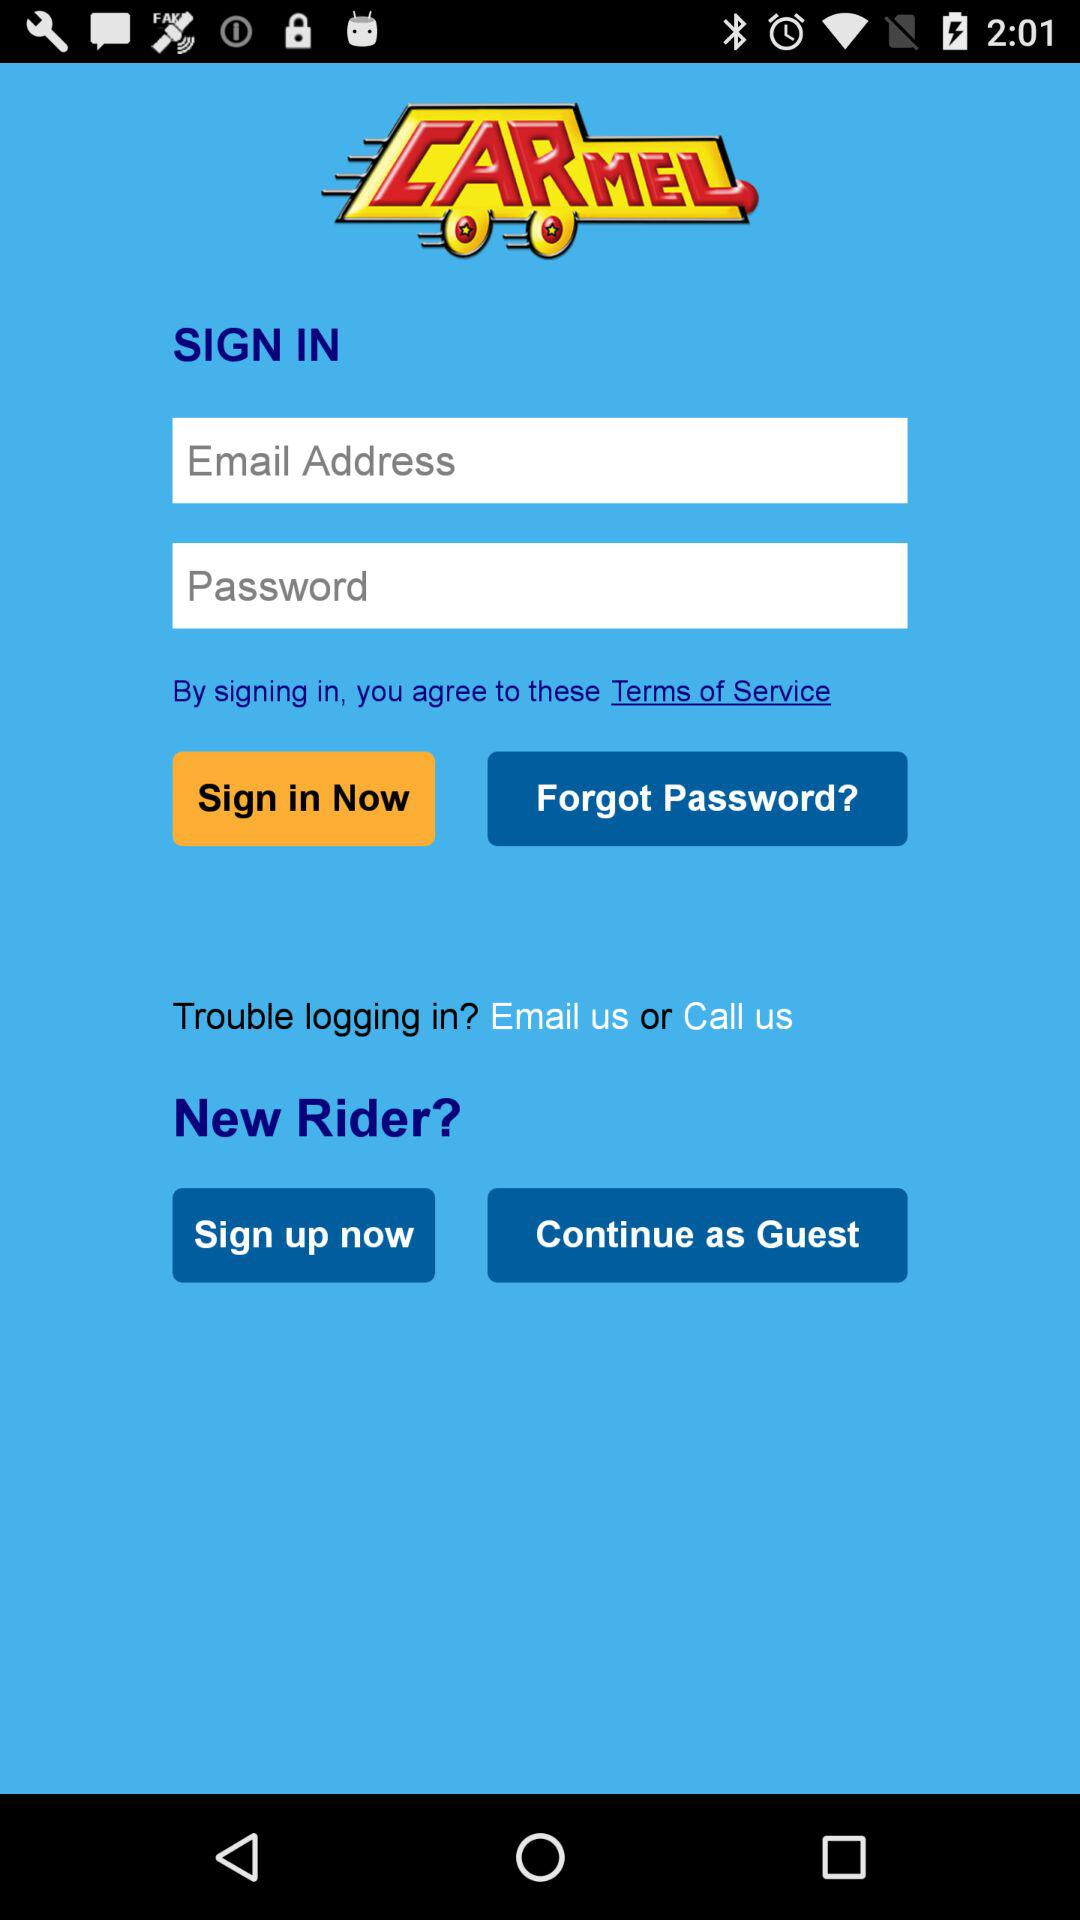What is the application name? The application name is "CARMEL". 